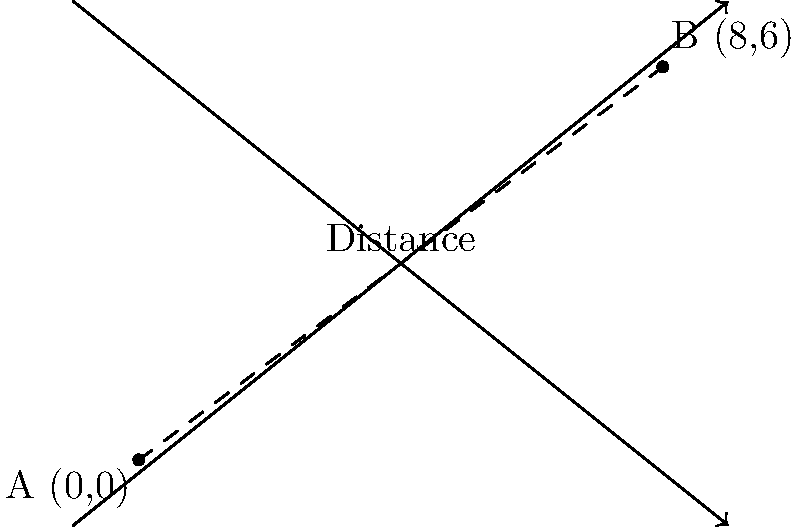As a dedicated sports fan, you're planning to attend games at two rival team's home arenas. The arenas are located on a coordinate plane, with Team A's arena at point A (0,0) and Team B's arena at point B (8,6). What is the straight-line distance between these two arenas? To find the distance between two points on a coordinate plane, we can use the distance formula:

$$d = \sqrt{(x_2 - x_1)^2 + (y_2 - y_1)^2}$$

Where $(x_1, y_1)$ are the coordinates of the first point and $(x_2, y_2)$ are the coordinates of the second point.

Let's plug in our values:
1. Point A: $(x_1, y_1) = (0, 0)$
2. Point B: $(x_2, y_2) = (8, 6)$

Now, let's calculate:

$$\begin{align}
d &= \sqrt{(8 - 0)^2 + (6 - 0)^2} \\
&= \sqrt{8^2 + 6^2} \\
&= \sqrt{64 + 36} \\
&= \sqrt{100} \\
&= 10
\end{align}$$

Therefore, the straight-line distance between the two arenas is 10 units.
Answer: 10 units 